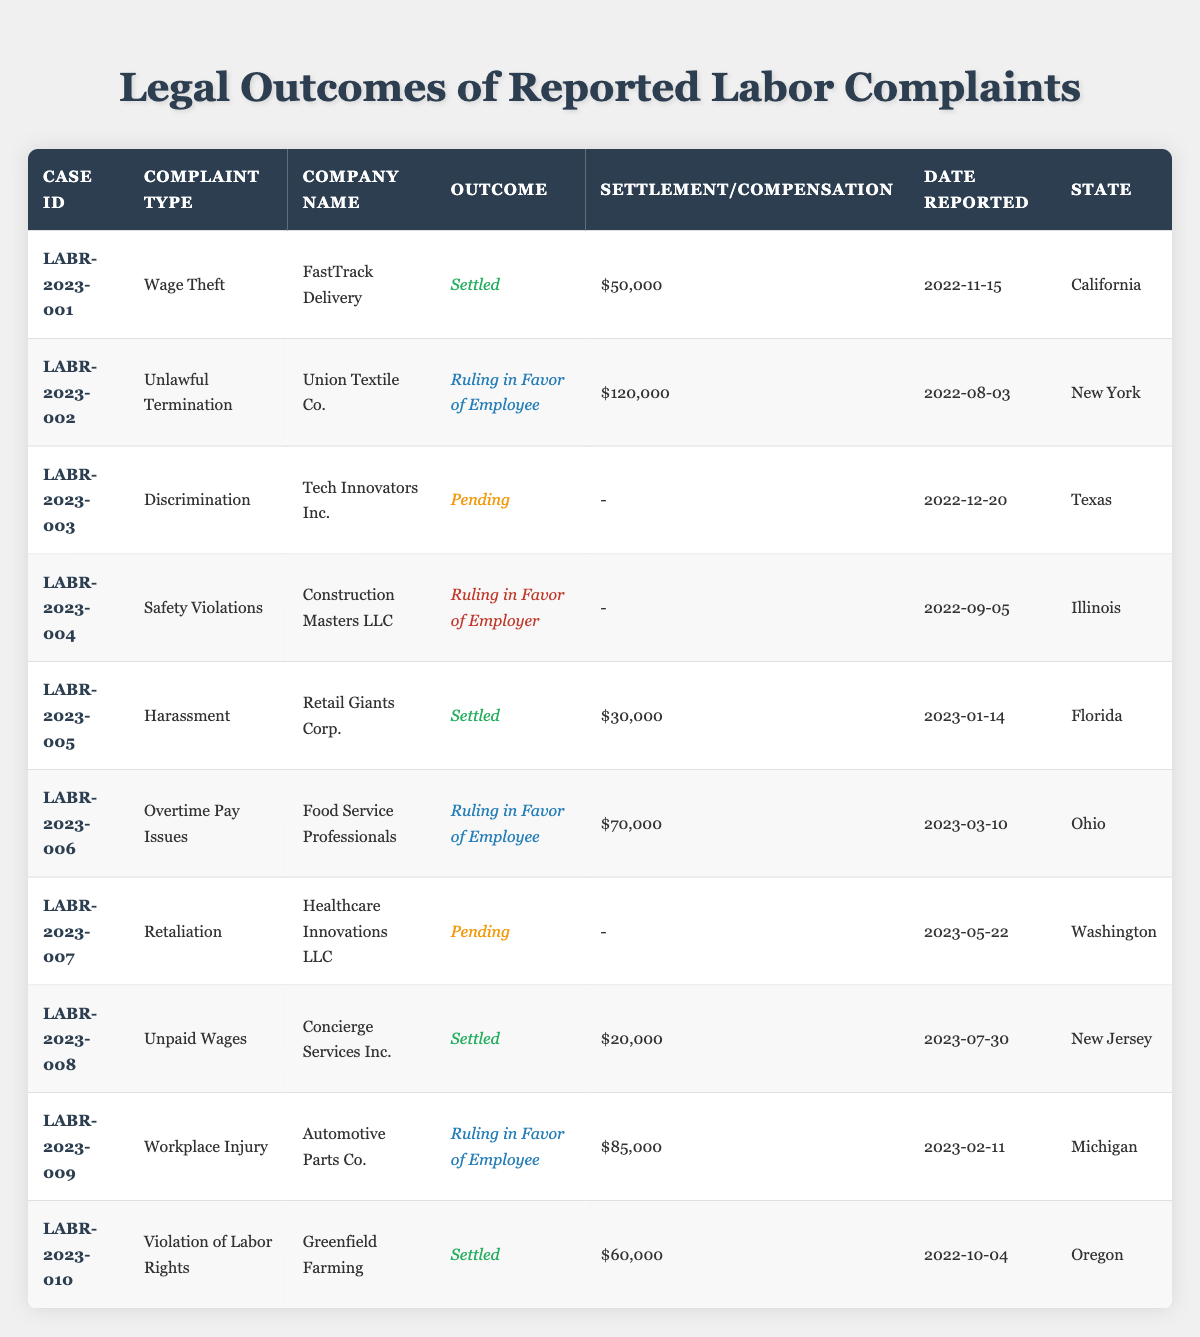What is the total settlement amount for all settled cases? The settled cases are LABR-2023-001 ($50,000), LABR-2023-005 ($30,000), LABR-2023-008 ($20,000), and LABR-2023-010 ($60,000). Summing these amounts: 50,000 + 30,000 + 20,000 + 60,000 = 160,000.
Answer: 160,000 How many cases were decided in favor of the employee? The cases decided in favor of the employee are LABR-2023-002, LABR-2023-006, and LABR-2023-009, totaling 3 cases.
Answer: 3 What was the highest compensation awarded in a single case? The highest compensation awarded is $120,000 from LABR-2023-002.
Answer: 120,000 What percentage of complaints resulted in settlements? There are 10 cases total, and 4 of them resulted in settlements (LABR-2023-001, LABR-2023-005, LABR-2023-008, and LABR-2023-010). The percentage is (4 settled cases / 10 total cases) * 100 = 40%.
Answer: 40% Is there any case that is still pending? Yes, there are two pending cases: LABR-2023-003 and LABR-2023-007.
Answer: Yes What is the average settlement amount for the settled cases? The settled cases are LABR-2023-001 ($50,000), LABR-2023-005 ($30,000), LABR-2023-008 ($20,000), and LABR-2023-010 ($60,000). The sum is 50,000 + 30,000 + 20,000 + 60,000 = 160,000. There are 4 settled cases, so the average is 160,000 / 4 = 40,000.
Answer: 40,000 Which state had the most cases decided in favor of the employer? The only case decided in favor of the employer is LABR-2023-004 from Illinois, so Illinois is the state with the most cases ruled in favor of the employer, which is 1 case.
Answer: Illinois How many different types of complaints were reported? There are 10 cases with 7 unique complaint types: Wage Theft, Unlawful Termination, Discrimination, Safety Violations, Harassment, Overtime Pay Issues, and Retaliation.
Answer: 7 What is the outcome of the case reported on 2023-05-22? The case reported on 2023-05-22 is LABR-2023-007, which is still pending.
Answer: Pending How many cases have the same complaint type as LABR-2023-006? LABR-2023-006 concerns Overtime Pay Issues, which is only reported once in the data. Thus, it corresponds to 1 case.
Answer: 1 What is the total number of cases reported in Florida? There is 1 case reported in Florida, which is LABR-2023-005.
Answer: 1 What was the outcome of the case from Tech Innovators Inc.? The outcome of the case from Tech Innovators Inc. is pending as indicated in LABR-2023-003.
Answer: Pending 